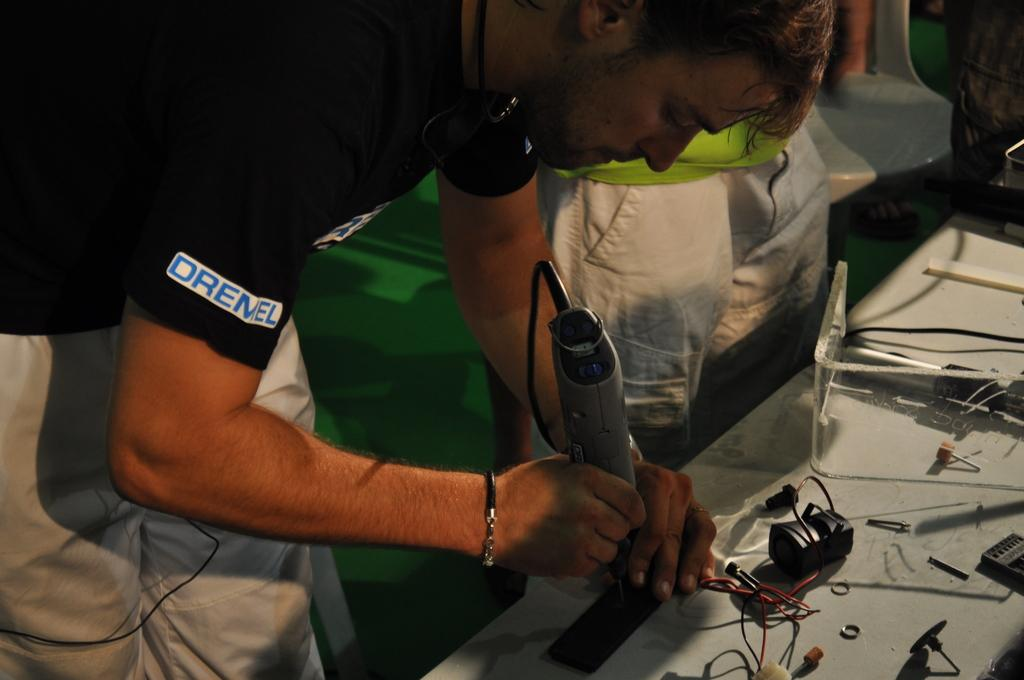<image>
Provide a brief description of the given image. A man with a dremel shirt fixing a product 